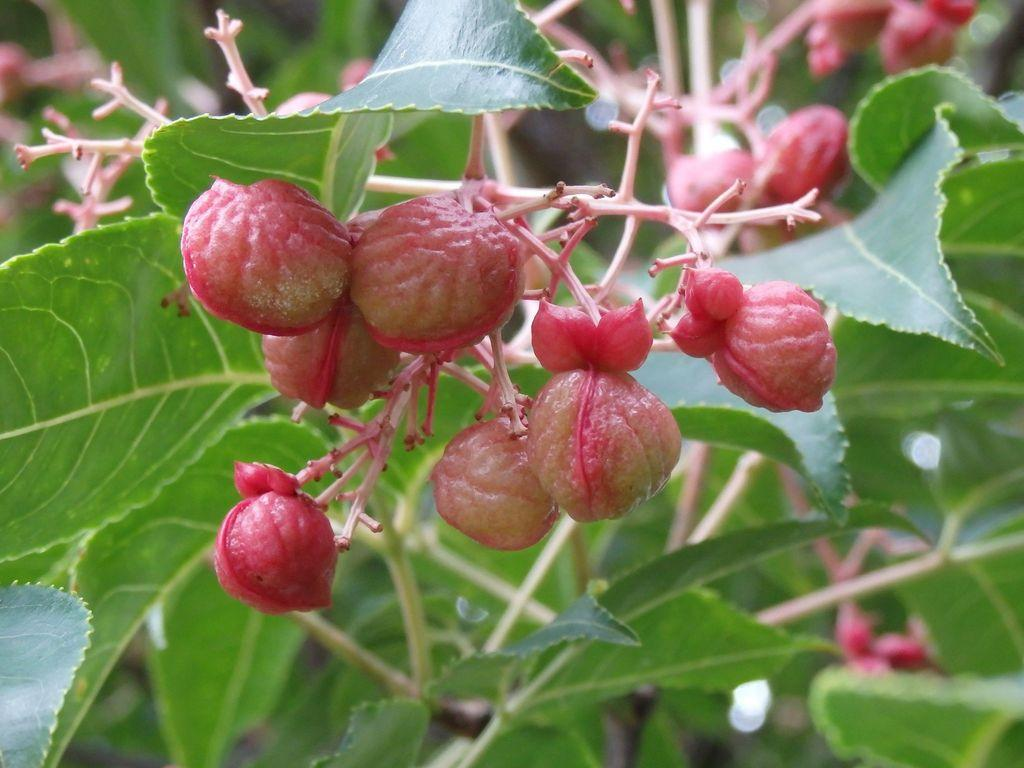What color are the fruits in the image? The fruits in the image are pink. Where are the fruits located in the image? The fruits are in the middle of the image. What can be seen in the background of the image? There are green leaves in the background of the image. How are the green leaves positioned in relation to the fruits? The green leaves are around the fruits. How many toes can be seen on the fruits in the image? There are no toes visible in the image, as the main subjects are fruits and leaves. 